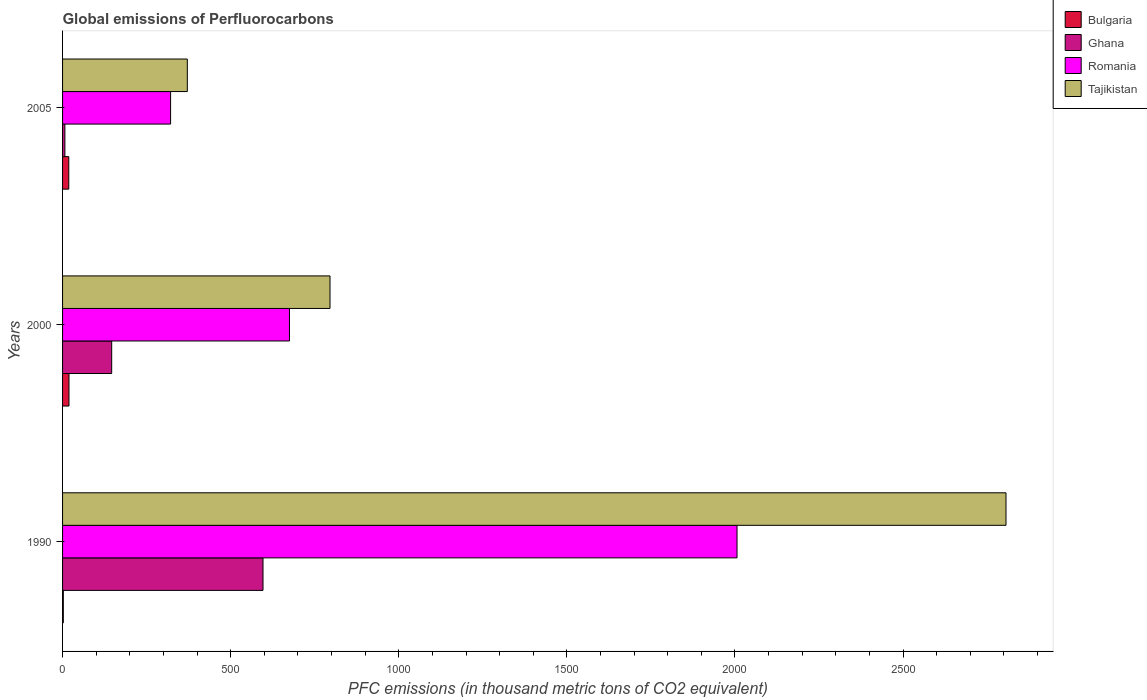Are the number of bars on each tick of the Y-axis equal?
Offer a very short reply. Yes. What is the label of the 3rd group of bars from the top?
Give a very brief answer. 1990. In how many cases, is the number of bars for a given year not equal to the number of legend labels?
Ensure brevity in your answer.  0. Across all years, what is the maximum global emissions of Perfluorocarbons in Ghana?
Offer a terse response. 596.2. Across all years, what is the minimum global emissions of Perfluorocarbons in Bulgaria?
Keep it short and to the point. 2.2. What is the total global emissions of Perfluorocarbons in Ghana in the graph?
Offer a very short reply. 749.2. What is the difference between the global emissions of Perfluorocarbons in Bulgaria in 2000 and that in 2005?
Provide a short and direct response. 0.6. What is the difference between the global emissions of Perfluorocarbons in Bulgaria in 2005 and the global emissions of Perfluorocarbons in Ghana in 2000?
Your answer should be compact. -127.6. What is the average global emissions of Perfluorocarbons in Tajikistan per year?
Give a very brief answer. 1324.23. In the year 2000, what is the difference between the global emissions of Perfluorocarbons in Romania and global emissions of Perfluorocarbons in Tajikistan?
Your answer should be compact. -120.6. What is the ratio of the global emissions of Perfluorocarbons in Ghana in 1990 to that in 2000?
Provide a short and direct response. 4.08. Is the difference between the global emissions of Perfluorocarbons in Romania in 1990 and 2000 greater than the difference between the global emissions of Perfluorocarbons in Tajikistan in 1990 and 2000?
Offer a very short reply. No. What is the difference between the highest and the second highest global emissions of Perfluorocarbons in Romania?
Ensure brevity in your answer.  1331.2. What is the difference between the highest and the lowest global emissions of Perfluorocarbons in Romania?
Offer a very short reply. 1684.8. What does the 2nd bar from the top in 1990 represents?
Your answer should be compact. Romania. What does the 4th bar from the bottom in 2005 represents?
Your response must be concise. Tajikistan. Is it the case that in every year, the sum of the global emissions of Perfluorocarbons in Tajikistan and global emissions of Perfluorocarbons in Romania is greater than the global emissions of Perfluorocarbons in Bulgaria?
Provide a short and direct response. Yes. How many bars are there?
Your answer should be very brief. 12. How many years are there in the graph?
Give a very brief answer. 3. Does the graph contain grids?
Give a very brief answer. No. How many legend labels are there?
Your answer should be compact. 4. What is the title of the graph?
Your answer should be compact. Global emissions of Perfluorocarbons. Does "Vanuatu" appear as one of the legend labels in the graph?
Provide a short and direct response. No. What is the label or title of the X-axis?
Your response must be concise. PFC emissions (in thousand metric tons of CO2 equivalent). What is the label or title of the Y-axis?
Offer a very short reply. Years. What is the PFC emissions (in thousand metric tons of CO2 equivalent) of Bulgaria in 1990?
Your answer should be compact. 2.2. What is the PFC emissions (in thousand metric tons of CO2 equivalent) in Ghana in 1990?
Your answer should be compact. 596.2. What is the PFC emissions (in thousand metric tons of CO2 equivalent) of Romania in 1990?
Your answer should be compact. 2006.1. What is the PFC emissions (in thousand metric tons of CO2 equivalent) of Tajikistan in 1990?
Your answer should be very brief. 2806.1. What is the PFC emissions (in thousand metric tons of CO2 equivalent) in Ghana in 2000?
Offer a terse response. 146.1. What is the PFC emissions (in thousand metric tons of CO2 equivalent) in Romania in 2000?
Your answer should be very brief. 674.9. What is the PFC emissions (in thousand metric tons of CO2 equivalent) of Tajikistan in 2000?
Your answer should be very brief. 795.5. What is the PFC emissions (in thousand metric tons of CO2 equivalent) of Bulgaria in 2005?
Keep it short and to the point. 18.5. What is the PFC emissions (in thousand metric tons of CO2 equivalent) of Ghana in 2005?
Offer a very short reply. 6.9. What is the PFC emissions (in thousand metric tons of CO2 equivalent) in Romania in 2005?
Your answer should be compact. 321.3. What is the PFC emissions (in thousand metric tons of CO2 equivalent) of Tajikistan in 2005?
Your answer should be compact. 371.1. Across all years, what is the maximum PFC emissions (in thousand metric tons of CO2 equivalent) of Ghana?
Offer a very short reply. 596.2. Across all years, what is the maximum PFC emissions (in thousand metric tons of CO2 equivalent) in Romania?
Give a very brief answer. 2006.1. Across all years, what is the maximum PFC emissions (in thousand metric tons of CO2 equivalent) in Tajikistan?
Your answer should be compact. 2806.1. Across all years, what is the minimum PFC emissions (in thousand metric tons of CO2 equivalent) in Romania?
Provide a succinct answer. 321.3. Across all years, what is the minimum PFC emissions (in thousand metric tons of CO2 equivalent) in Tajikistan?
Make the answer very short. 371.1. What is the total PFC emissions (in thousand metric tons of CO2 equivalent) of Bulgaria in the graph?
Your response must be concise. 39.8. What is the total PFC emissions (in thousand metric tons of CO2 equivalent) in Ghana in the graph?
Offer a very short reply. 749.2. What is the total PFC emissions (in thousand metric tons of CO2 equivalent) in Romania in the graph?
Give a very brief answer. 3002.3. What is the total PFC emissions (in thousand metric tons of CO2 equivalent) in Tajikistan in the graph?
Offer a very short reply. 3972.7. What is the difference between the PFC emissions (in thousand metric tons of CO2 equivalent) of Bulgaria in 1990 and that in 2000?
Offer a terse response. -16.9. What is the difference between the PFC emissions (in thousand metric tons of CO2 equivalent) of Ghana in 1990 and that in 2000?
Offer a terse response. 450.1. What is the difference between the PFC emissions (in thousand metric tons of CO2 equivalent) of Romania in 1990 and that in 2000?
Your answer should be very brief. 1331.2. What is the difference between the PFC emissions (in thousand metric tons of CO2 equivalent) in Tajikistan in 1990 and that in 2000?
Give a very brief answer. 2010.6. What is the difference between the PFC emissions (in thousand metric tons of CO2 equivalent) of Bulgaria in 1990 and that in 2005?
Your answer should be very brief. -16.3. What is the difference between the PFC emissions (in thousand metric tons of CO2 equivalent) in Ghana in 1990 and that in 2005?
Your answer should be compact. 589.3. What is the difference between the PFC emissions (in thousand metric tons of CO2 equivalent) in Romania in 1990 and that in 2005?
Ensure brevity in your answer.  1684.8. What is the difference between the PFC emissions (in thousand metric tons of CO2 equivalent) in Tajikistan in 1990 and that in 2005?
Ensure brevity in your answer.  2435. What is the difference between the PFC emissions (in thousand metric tons of CO2 equivalent) in Bulgaria in 2000 and that in 2005?
Keep it short and to the point. 0.6. What is the difference between the PFC emissions (in thousand metric tons of CO2 equivalent) in Ghana in 2000 and that in 2005?
Offer a very short reply. 139.2. What is the difference between the PFC emissions (in thousand metric tons of CO2 equivalent) in Romania in 2000 and that in 2005?
Offer a terse response. 353.6. What is the difference between the PFC emissions (in thousand metric tons of CO2 equivalent) of Tajikistan in 2000 and that in 2005?
Your response must be concise. 424.4. What is the difference between the PFC emissions (in thousand metric tons of CO2 equivalent) of Bulgaria in 1990 and the PFC emissions (in thousand metric tons of CO2 equivalent) of Ghana in 2000?
Offer a very short reply. -143.9. What is the difference between the PFC emissions (in thousand metric tons of CO2 equivalent) of Bulgaria in 1990 and the PFC emissions (in thousand metric tons of CO2 equivalent) of Romania in 2000?
Offer a terse response. -672.7. What is the difference between the PFC emissions (in thousand metric tons of CO2 equivalent) in Bulgaria in 1990 and the PFC emissions (in thousand metric tons of CO2 equivalent) in Tajikistan in 2000?
Give a very brief answer. -793.3. What is the difference between the PFC emissions (in thousand metric tons of CO2 equivalent) of Ghana in 1990 and the PFC emissions (in thousand metric tons of CO2 equivalent) of Romania in 2000?
Your answer should be very brief. -78.7. What is the difference between the PFC emissions (in thousand metric tons of CO2 equivalent) of Ghana in 1990 and the PFC emissions (in thousand metric tons of CO2 equivalent) of Tajikistan in 2000?
Ensure brevity in your answer.  -199.3. What is the difference between the PFC emissions (in thousand metric tons of CO2 equivalent) in Romania in 1990 and the PFC emissions (in thousand metric tons of CO2 equivalent) in Tajikistan in 2000?
Give a very brief answer. 1210.6. What is the difference between the PFC emissions (in thousand metric tons of CO2 equivalent) of Bulgaria in 1990 and the PFC emissions (in thousand metric tons of CO2 equivalent) of Ghana in 2005?
Your answer should be very brief. -4.7. What is the difference between the PFC emissions (in thousand metric tons of CO2 equivalent) of Bulgaria in 1990 and the PFC emissions (in thousand metric tons of CO2 equivalent) of Romania in 2005?
Offer a very short reply. -319.1. What is the difference between the PFC emissions (in thousand metric tons of CO2 equivalent) of Bulgaria in 1990 and the PFC emissions (in thousand metric tons of CO2 equivalent) of Tajikistan in 2005?
Keep it short and to the point. -368.9. What is the difference between the PFC emissions (in thousand metric tons of CO2 equivalent) of Ghana in 1990 and the PFC emissions (in thousand metric tons of CO2 equivalent) of Romania in 2005?
Give a very brief answer. 274.9. What is the difference between the PFC emissions (in thousand metric tons of CO2 equivalent) in Ghana in 1990 and the PFC emissions (in thousand metric tons of CO2 equivalent) in Tajikistan in 2005?
Give a very brief answer. 225.1. What is the difference between the PFC emissions (in thousand metric tons of CO2 equivalent) of Romania in 1990 and the PFC emissions (in thousand metric tons of CO2 equivalent) of Tajikistan in 2005?
Give a very brief answer. 1635. What is the difference between the PFC emissions (in thousand metric tons of CO2 equivalent) of Bulgaria in 2000 and the PFC emissions (in thousand metric tons of CO2 equivalent) of Romania in 2005?
Provide a short and direct response. -302.2. What is the difference between the PFC emissions (in thousand metric tons of CO2 equivalent) in Bulgaria in 2000 and the PFC emissions (in thousand metric tons of CO2 equivalent) in Tajikistan in 2005?
Provide a short and direct response. -352. What is the difference between the PFC emissions (in thousand metric tons of CO2 equivalent) of Ghana in 2000 and the PFC emissions (in thousand metric tons of CO2 equivalent) of Romania in 2005?
Make the answer very short. -175.2. What is the difference between the PFC emissions (in thousand metric tons of CO2 equivalent) of Ghana in 2000 and the PFC emissions (in thousand metric tons of CO2 equivalent) of Tajikistan in 2005?
Ensure brevity in your answer.  -225. What is the difference between the PFC emissions (in thousand metric tons of CO2 equivalent) in Romania in 2000 and the PFC emissions (in thousand metric tons of CO2 equivalent) in Tajikistan in 2005?
Provide a short and direct response. 303.8. What is the average PFC emissions (in thousand metric tons of CO2 equivalent) of Bulgaria per year?
Offer a terse response. 13.27. What is the average PFC emissions (in thousand metric tons of CO2 equivalent) in Ghana per year?
Your answer should be compact. 249.73. What is the average PFC emissions (in thousand metric tons of CO2 equivalent) of Romania per year?
Your answer should be compact. 1000.77. What is the average PFC emissions (in thousand metric tons of CO2 equivalent) of Tajikistan per year?
Your response must be concise. 1324.23. In the year 1990, what is the difference between the PFC emissions (in thousand metric tons of CO2 equivalent) in Bulgaria and PFC emissions (in thousand metric tons of CO2 equivalent) in Ghana?
Offer a terse response. -594. In the year 1990, what is the difference between the PFC emissions (in thousand metric tons of CO2 equivalent) in Bulgaria and PFC emissions (in thousand metric tons of CO2 equivalent) in Romania?
Make the answer very short. -2003.9. In the year 1990, what is the difference between the PFC emissions (in thousand metric tons of CO2 equivalent) of Bulgaria and PFC emissions (in thousand metric tons of CO2 equivalent) of Tajikistan?
Your answer should be very brief. -2803.9. In the year 1990, what is the difference between the PFC emissions (in thousand metric tons of CO2 equivalent) in Ghana and PFC emissions (in thousand metric tons of CO2 equivalent) in Romania?
Keep it short and to the point. -1409.9. In the year 1990, what is the difference between the PFC emissions (in thousand metric tons of CO2 equivalent) of Ghana and PFC emissions (in thousand metric tons of CO2 equivalent) of Tajikistan?
Your response must be concise. -2209.9. In the year 1990, what is the difference between the PFC emissions (in thousand metric tons of CO2 equivalent) of Romania and PFC emissions (in thousand metric tons of CO2 equivalent) of Tajikistan?
Give a very brief answer. -800. In the year 2000, what is the difference between the PFC emissions (in thousand metric tons of CO2 equivalent) in Bulgaria and PFC emissions (in thousand metric tons of CO2 equivalent) in Ghana?
Your response must be concise. -127. In the year 2000, what is the difference between the PFC emissions (in thousand metric tons of CO2 equivalent) of Bulgaria and PFC emissions (in thousand metric tons of CO2 equivalent) of Romania?
Offer a terse response. -655.8. In the year 2000, what is the difference between the PFC emissions (in thousand metric tons of CO2 equivalent) of Bulgaria and PFC emissions (in thousand metric tons of CO2 equivalent) of Tajikistan?
Ensure brevity in your answer.  -776.4. In the year 2000, what is the difference between the PFC emissions (in thousand metric tons of CO2 equivalent) in Ghana and PFC emissions (in thousand metric tons of CO2 equivalent) in Romania?
Offer a very short reply. -528.8. In the year 2000, what is the difference between the PFC emissions (in thousand metric tons of CO2 equivalent) of Ghana and PFC emissions (in thousand metric tons of CO2 equivalent) of Tajikistan?
Your response must be concise. -649.4. In the year 2000, what is the difference between the PFC emissions (in thousand metric tons of CO2 equivalent) in Romania and PFC emissions (in thousand metric tons of CO2 equivalent) in Tajikistan?
Make the answer very short. -120.6. In the year 2005, what is the difference between the PFC emissions (in thousand metric tons of CO2 equivalent) in Bulgaria and PFC emissions (in thousand metric tons of CO2 equivalent) in Romania?
Your response must be concise. -302.8. In the year 2005, what is the difference between the PFC emissions (in thousand metric tons of CO2 equivalent) in Bulgaria and PFC emissions (in thousand metric tons of CO2 equivalent) in Tajikistan?
Your answer should be very brief. -352.6. In the year 2005, what is the difference between the PFC emissions (in thousand metric tons of CO2 equivalent) of Ghana and PFC emissions (in thousand metric tons of CO2 equivalent) of Romania?
Your answer should be very brief. -314.4. In the year 2005, what is the difference between the PFC emissions (in thousand metric tons of CO2 equivalent) of Ghana and PFC emissions (in thousand metric tons of CO2 equivalent) of Tajikistan?
Offer a terse response. -364.2. In the year 2005, what is the difference between the PFC emissions (in thousand metric tons of CO2 equivalent) in Romania and PFC emissions (in thousand metric tons of CO2 equivalent) in Tajikistan?
Offer a terse response. -49.8. What is the ratio of the PFC emissions (in thousand metric tons of CO2 equivalent) in Bulgaria in 1990 to that in 2000?
Offer a terse response. 0.12. What is the ratio of the PFC emissions (in thousand metric tons of CO2 equivalent) in Ghana in 1990 to that in 2000?
Offer a very short reply. 4.08. What is the ratio of the PFC emissions (in thousand metric tons of CO2 equivalent) in Romania in 1990 to that in 2000?
Ensure brevity in your answer.  2.97. What is the ratio of the PFC emissions (in thousand metric tons of CO2 equivalent) in Tajikistan in 1990 to that in 2000?
Provide a succinct answer. 3.53. What is the ratio of the PFC emissions (in thousand metric tons of CO2 equivalent) in Bulgaria in 1990 to that in 2005?
Your response must be concise. 0.12. What is the ratio of the PFC emissions (in thousand metric tons of CO2 equivalent) of Ghana in 1990 to that in 2005?
Give a very brief answer. 86.41. What is the ratio of the PFC emissions (in thousand metric tons of CO2 equivalent) of Romania in 1990 to that in 2005?
Your response must be concise. 6.24. What is the ratio of the PFC emissions (in thousand metric tons of CO2 equivalent) in Tajikistan in 1990 to that in 2005?
Make the answer very short. 7.56. What is the ratio of the PFC emissions (in thousand metric tons of CO2 equivalent) of Bulgaria in 2000 to that in 2005?
Give a very brief answer. 1.03. What is the ratio of the PFC emissions (in thousand metric tons of CO2 equivalent) in Ghana in 2000 to that in 2005?
Give a very brief answer. 21.17. What is the ratio of the PFC emissions (in thousand metric tons of CO2 equivalent) in Romania in 2000 to that in 2005?
Provide a succinct answer. 2.1. What is the ratio of the PFC emissions (in thousand metric tons of CO2 equivalent) in Tajikistan in 2000 to that in 2005?
Provide a succinct answer. 2.14. What is the difference between the highest and the second highest PFC emissions (in thousand metric tons of CO2 equivalent) in Ghana?
Your answer should be compact. 450.1. What is the difference between the highest and the second highest PFC emissions (in thousand metric tons of CO2 equivalent) of Romania?
Keep it short and to the point. 1331.2. What is the difference between the highest and the second highest PFC emissions (in thousand metric tons of CO2 equivalent) of Tajikistan?
Provide a short and direct response. 2010.6. What is the difference between the highest and the lowest PFC emissions (in thousand metric tons of CO2 equivalent) in Bulgaria?
Your response must be concise. 16.9. What is the difference between the highest and the lowest PFC emissions (in thousand metric tons of CO2 equivalent) of Ghana?
Ensure brevity in your answer.  589.3. What is the difference between the highest and the lowest PFC emissions (in thousand metric tons of CO2 equivalent) in Romania?
Provide a succinct answer. 1684.8. What is the difference between the highest and the lowest PFC emissions (in thousand metric tons of CO2 equivalent) of Tajikistan?
Keep it short and to the point. 2435. 